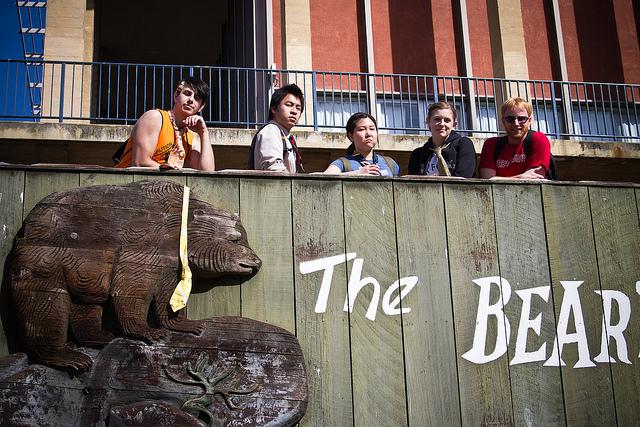What is on the sign?
Keep it brief. Bear. What is the animal carved out on the outside wall?
Keep it brief. Bear. How many people are posing?
Answer briefly. 5. 